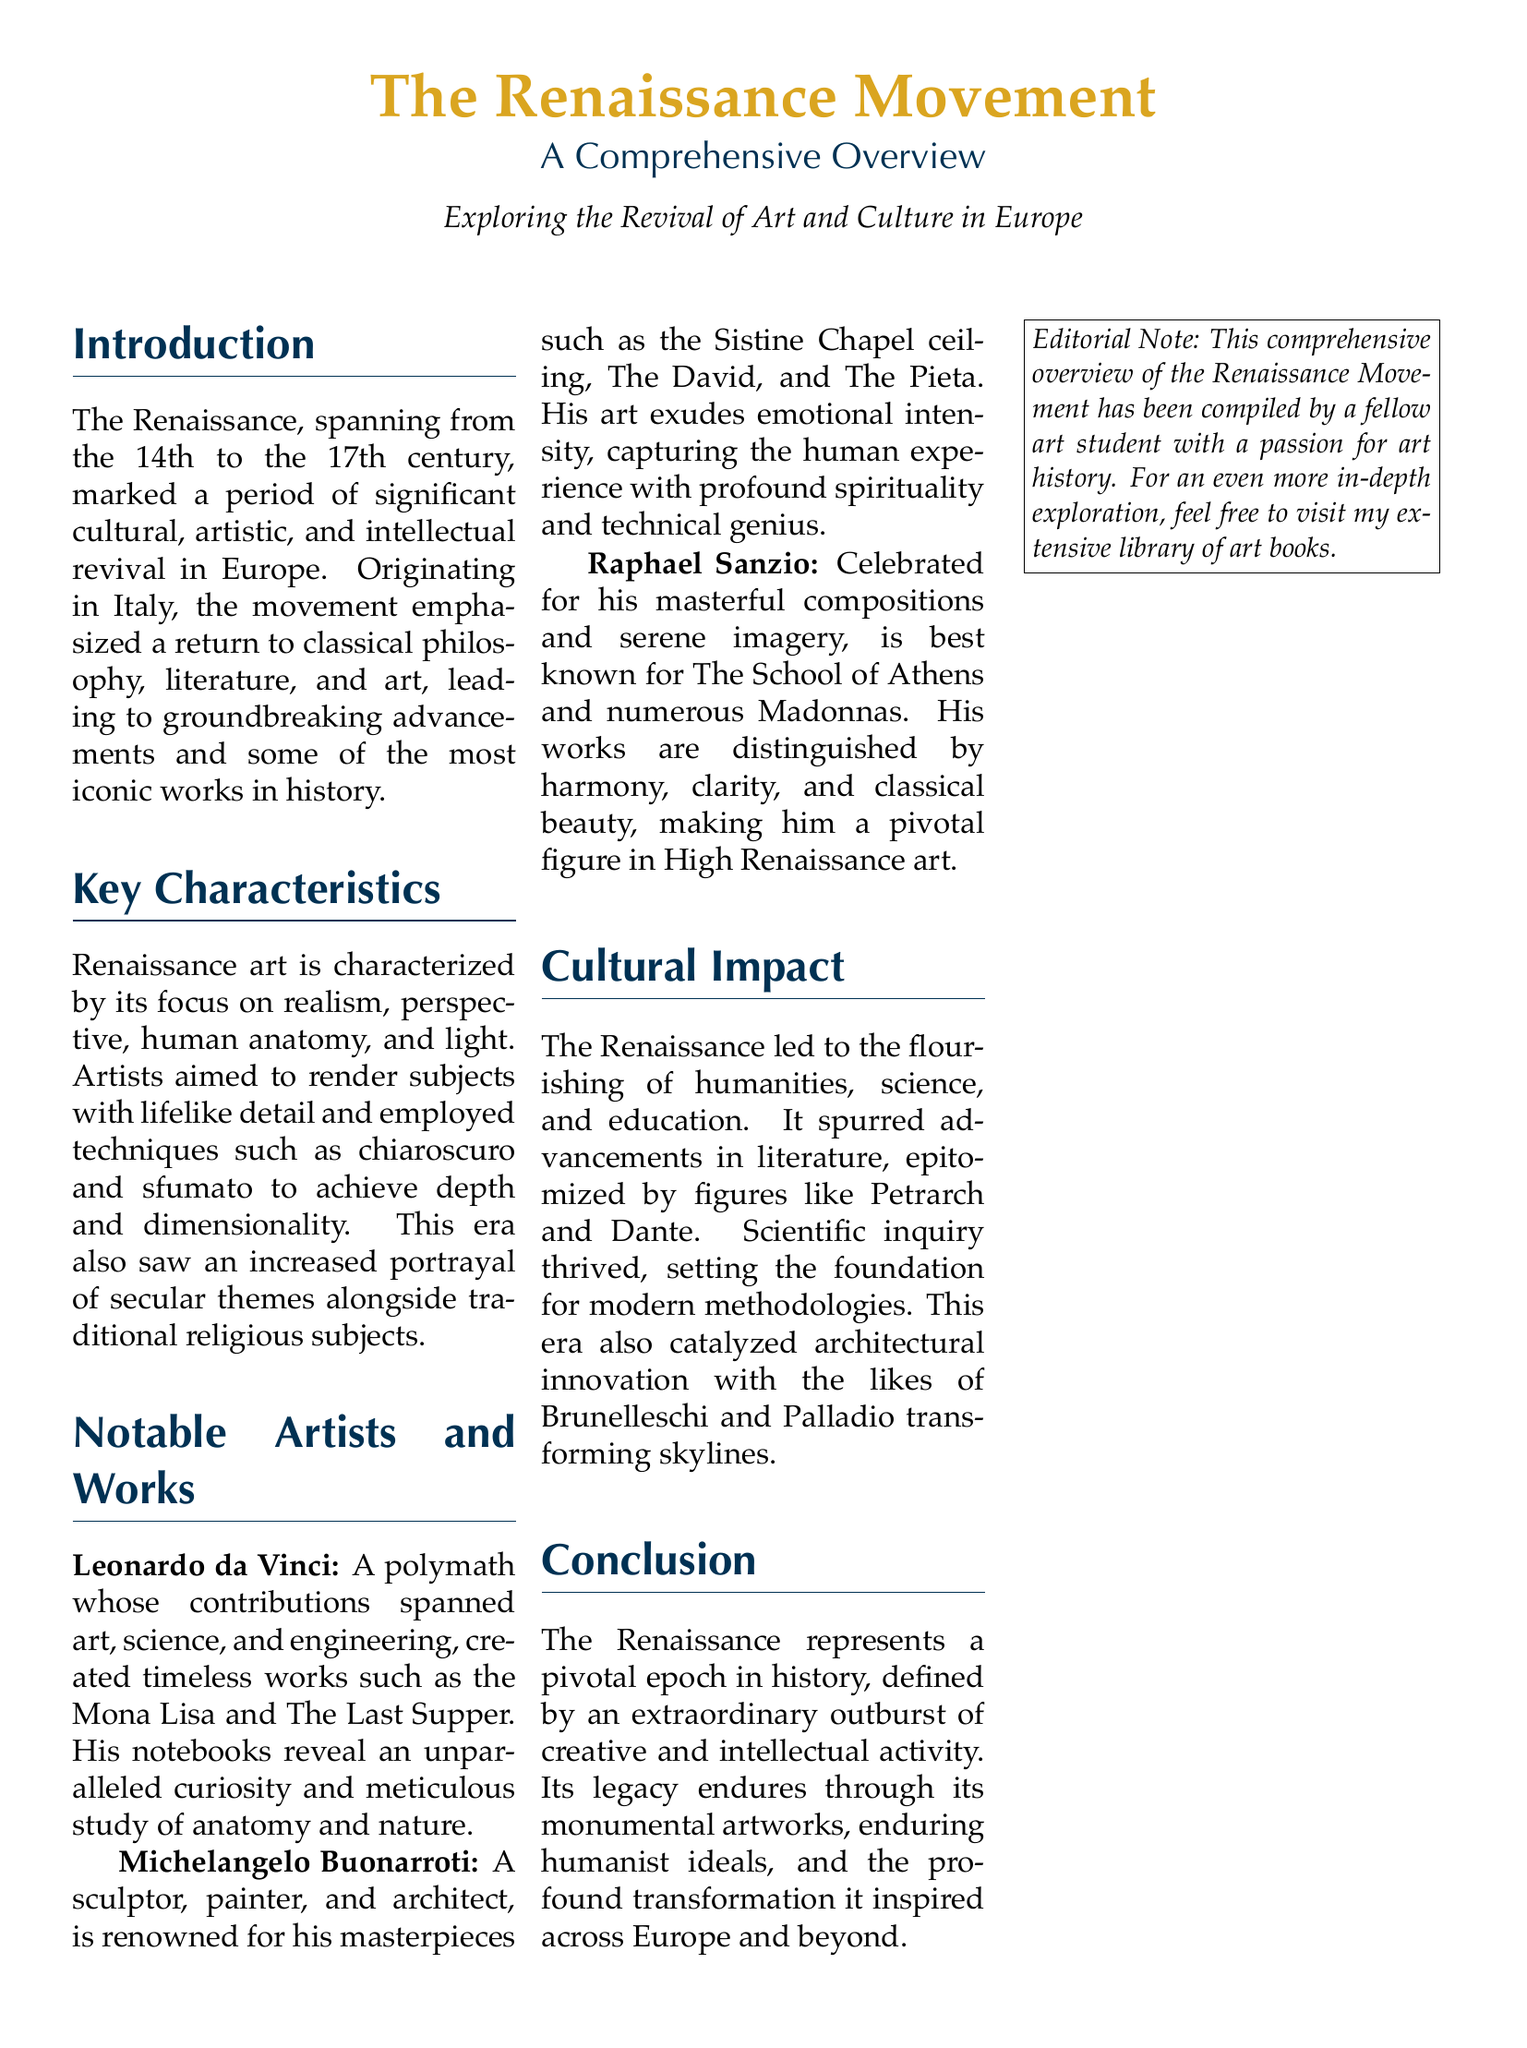what time period does the Renaissance span? The document states that the Renaissance spans from the 14th to the 17th century.
Answer: 14th to 17th century who is known for the painting "Mona Lisa"? The document mentions Leonardo da Vinci as the creator of "Mona Lisa".
Answer: Leonardo da Vinci what artistic technique is emphasized for depth in Renaissance art? The document highlights the use of chiaroscuro for achieving depth in art.
Answer: chiaroscuro which notable artist is recognized for the Sistine Chapel ceiling? The document identifies Michelangelo Buonarroti as the artist of the Sistine Chapel ceiling.
Answer: Michelangelo Buonarroti what is a significant effect of the Renaissance movement on literature? The document notes that it led to advancements in literature, exemplified by figures like Petrarch and Dante.
Answer: advancements in literature how is Raphael Sanzio’s work described in terms of imagery? The document describes Raphael Sanzio's work as masterful and serene.
Answer: masterful and serene which two architects transformed skylines during the Renaissance? The document mentions Brunelleschi and Palladio as key architects of the era.
Answer: Brunelleschi and Palladio what is the color scheme used for headings in this document? The document uses renaissanceblue for the headings.
Answer: renaissanceblue who compiled this overview of the Renaissance Movement? The document indicates that the overview was compiled by a fellow art student.
Answer: fellow art student 